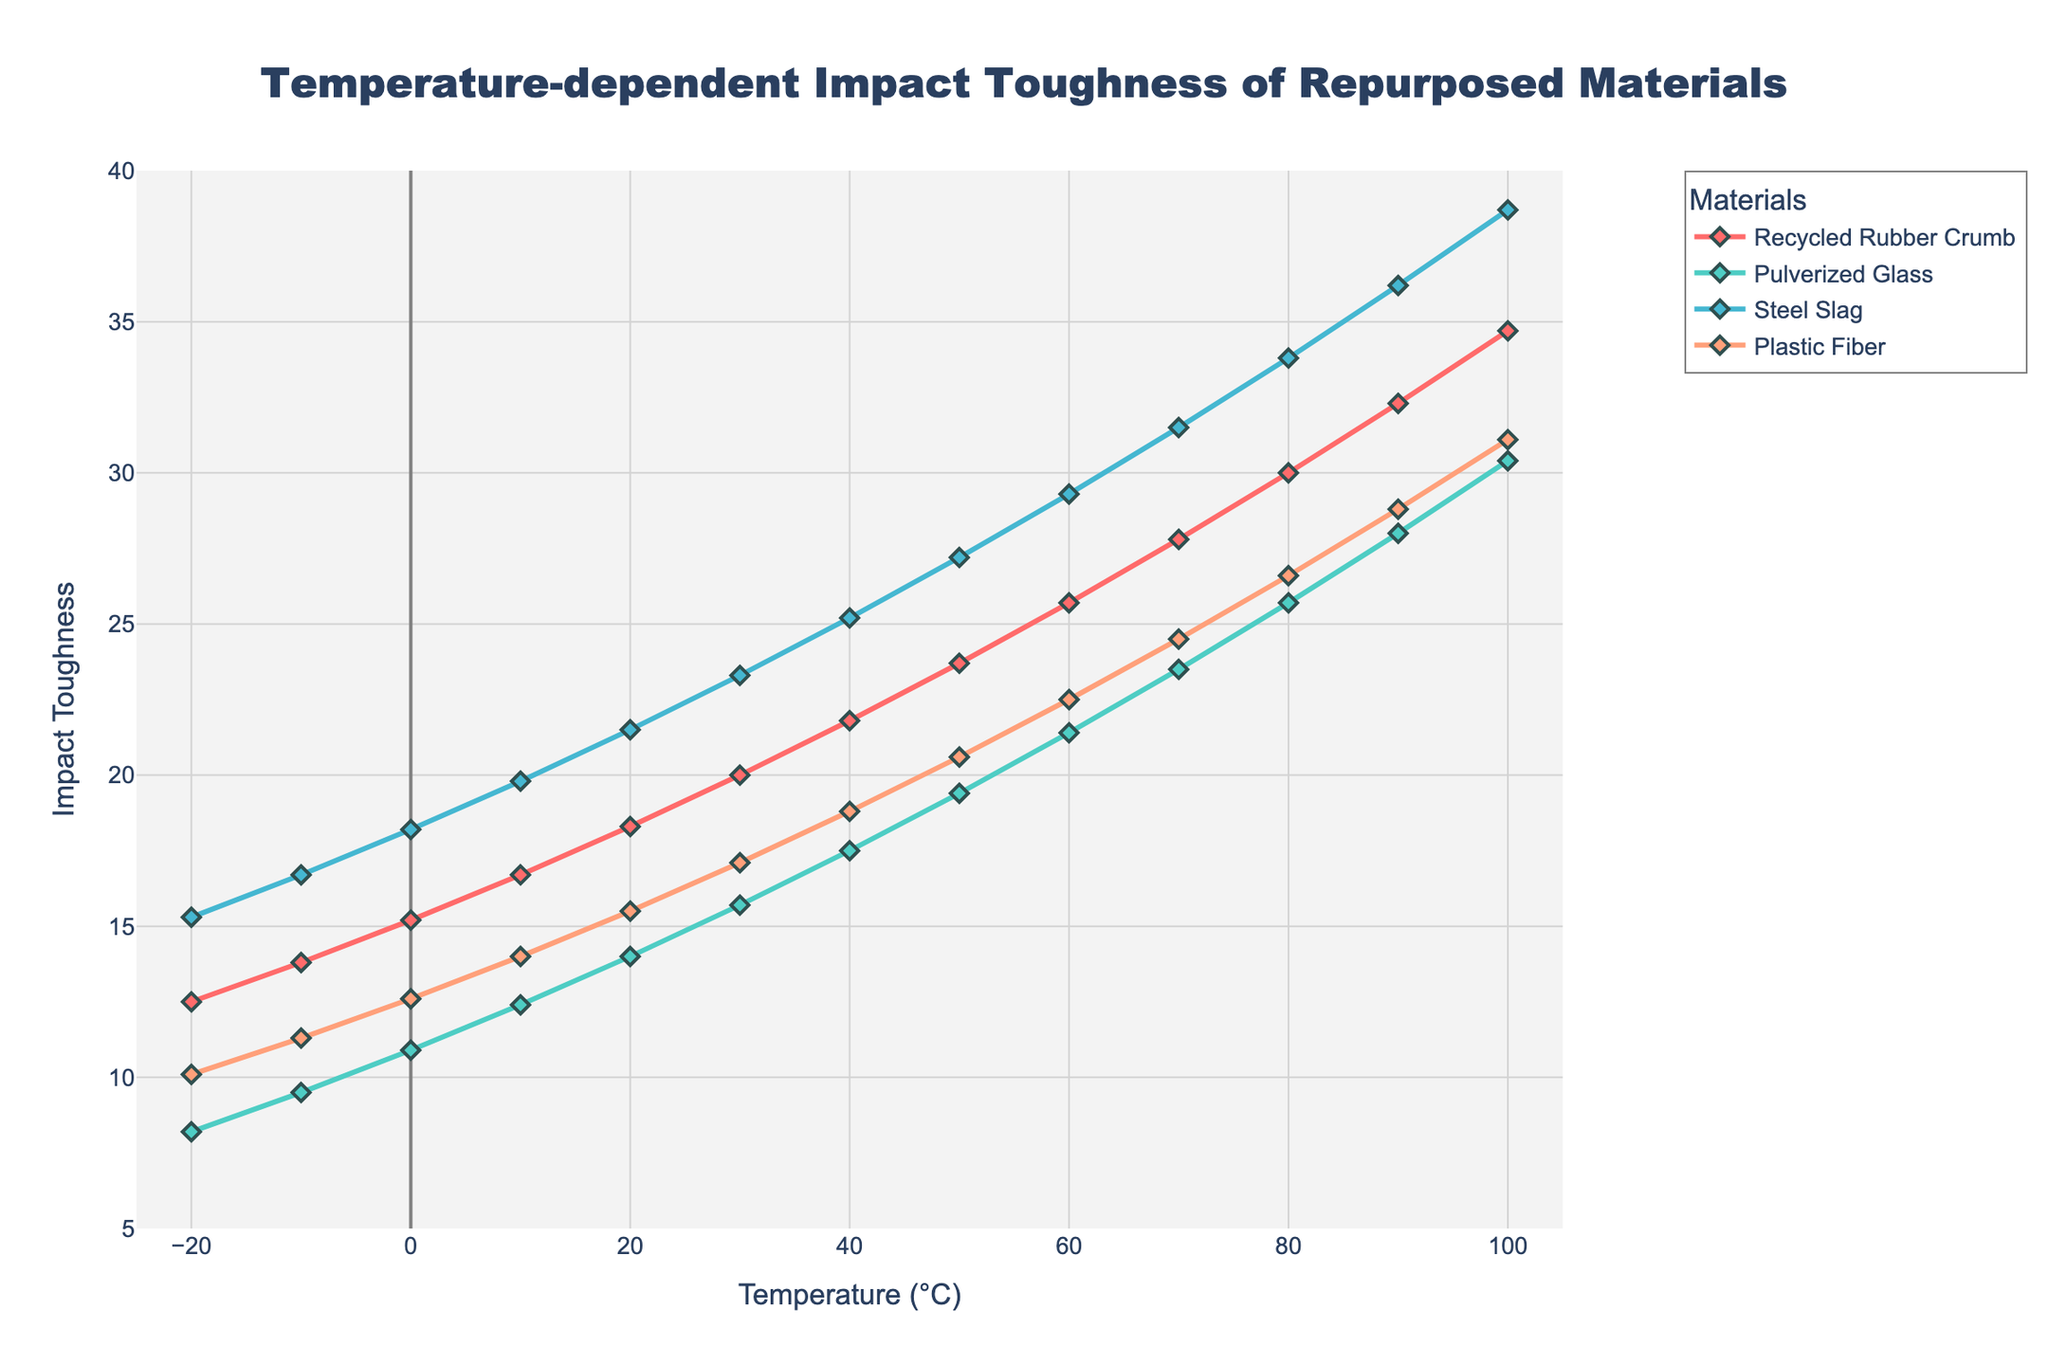Which material shows the highest impact toughness at 0°C? Look for the data points at 0°C in the line chart and find the highest value among all materials: Recycled Rubber Crumb (15.2), Pulverized Glass (10.9), Steel Slag (18.2), and Plastic Fiber (12.6). The highest is Steel Slag with an impact toughness of 18.2.
Answer: Steel Slag As temperature increases from -20°C to 100°C, which material shows the most consistent linear increase in impact toughness? Compare the linearity of the trend lines for each material across the temperature range. Recycled Rubber Crumb, Pulverized Glass, Steel Slag, and Plastic Fiber all show increases, but Steel Slag shows a consistently steady slope.
Answer: Steel Slag What is the total impact toughness of Plastic Fiber from -20°C to 100°C? Sum the impact toughness values for Plastic Fiber at each temperature: 10.1 + 11.3 + 12.6 + 14.0 + 15.5 + 17.1 + 18.8 + 20.6 + 22.5 + 24.5 + 26.6 + 28.8 + 31.1 = 253.5.
Answer: 253.5 Which material records the smallest increase in impact toughness from 50°C to 60°C? Calculate the increase in impact toughness for each material between 50°C and 60°C: Recycled Rubber Crumb (25.7 - 23.7 = 2.0), Pulverized Glass (21.4 - 19.4 = 2.0), Steel Slag (29.3 - 27.2 = 2.1), Plastic Fiber (22.5 - 20.6 = 1.9). The smallest increase is Plastic Fiber with 1.9.
Answer: Plastic Fiber At what temperature do Pulverized Glass and Plastic Fiber have the same impact toughness? Inspect the chart for the temperature where the lines for Pulverized Glass and Plastic Fiber intersect. At 60°C, both have an impact toughness of 21.4.
Answer: 60°C How much greater is the impact toughness of Steel Slag compared to Pulverized Glass at 80°C? At 80°C, find the difference between the impact toughness of Steel Slag (33.8) and Pulverized Glass (25.7): 33.8 - 25.7 = 8.1.
Answer: 8.1 What is the average impact toughness for Recycled Rubber Crumb across all temperatures? Calculate the average of all data points for Recycled Rubber Crumb: (12.5 + 13.8 + 15.2 + 16.7 + 18.3 + 20.0 + 21.8 + 23.7 + 25.7 + 27.8 + 30.0 + 32.3 + 34.7) / 13 = 22.14.
Answer: 22.14 Which material has the steepest slope in impact toughness from -20°C to 100°C? Compare the slopes of the lines for each material: Recycled Rubber Crumb (34.7-12.5), Pulverized Glass (30.4-8.2), Steel Slag (38.7-15.3), Plastic Fiber (31.1-10.1). The steepest slope is for Steel Slag, with the most significant difference.
Answer: Steel Slag Do Plastic Fiber and Recycled Rubber Crumb ever have the same impact toughness at any temperature? Examine the chart to check if the lines for Plastic Fiber and Recycled Rubber Crumb ever intersect. They do not intersect at any temperature.
Answer: No What is the median value of the Steel Slag impact toughness data points? Arrange the Steel Slag data points in ascending order and find the middle value: 15.3, 16.7, 18.2, 19.8, 21.5, 23.3, 25.2, 27.2, 29.3, 31.5, 33.8, 36.2, 38.7. The median value is the 7th value, which is 25.2.
Answer: 25.2 